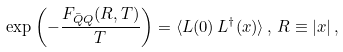<formula> <loc_0><loc_0><loc_500><loc_500>\exp \left ( - \frac { F _ { \bar { Q } Q } ( R , T ) } { T } \right ) = \langle L ( 0 ) \, L ^ { \dagger } ( { x } ) \rangle \, , \, R \equiv | { x } | \, ,</formula> 